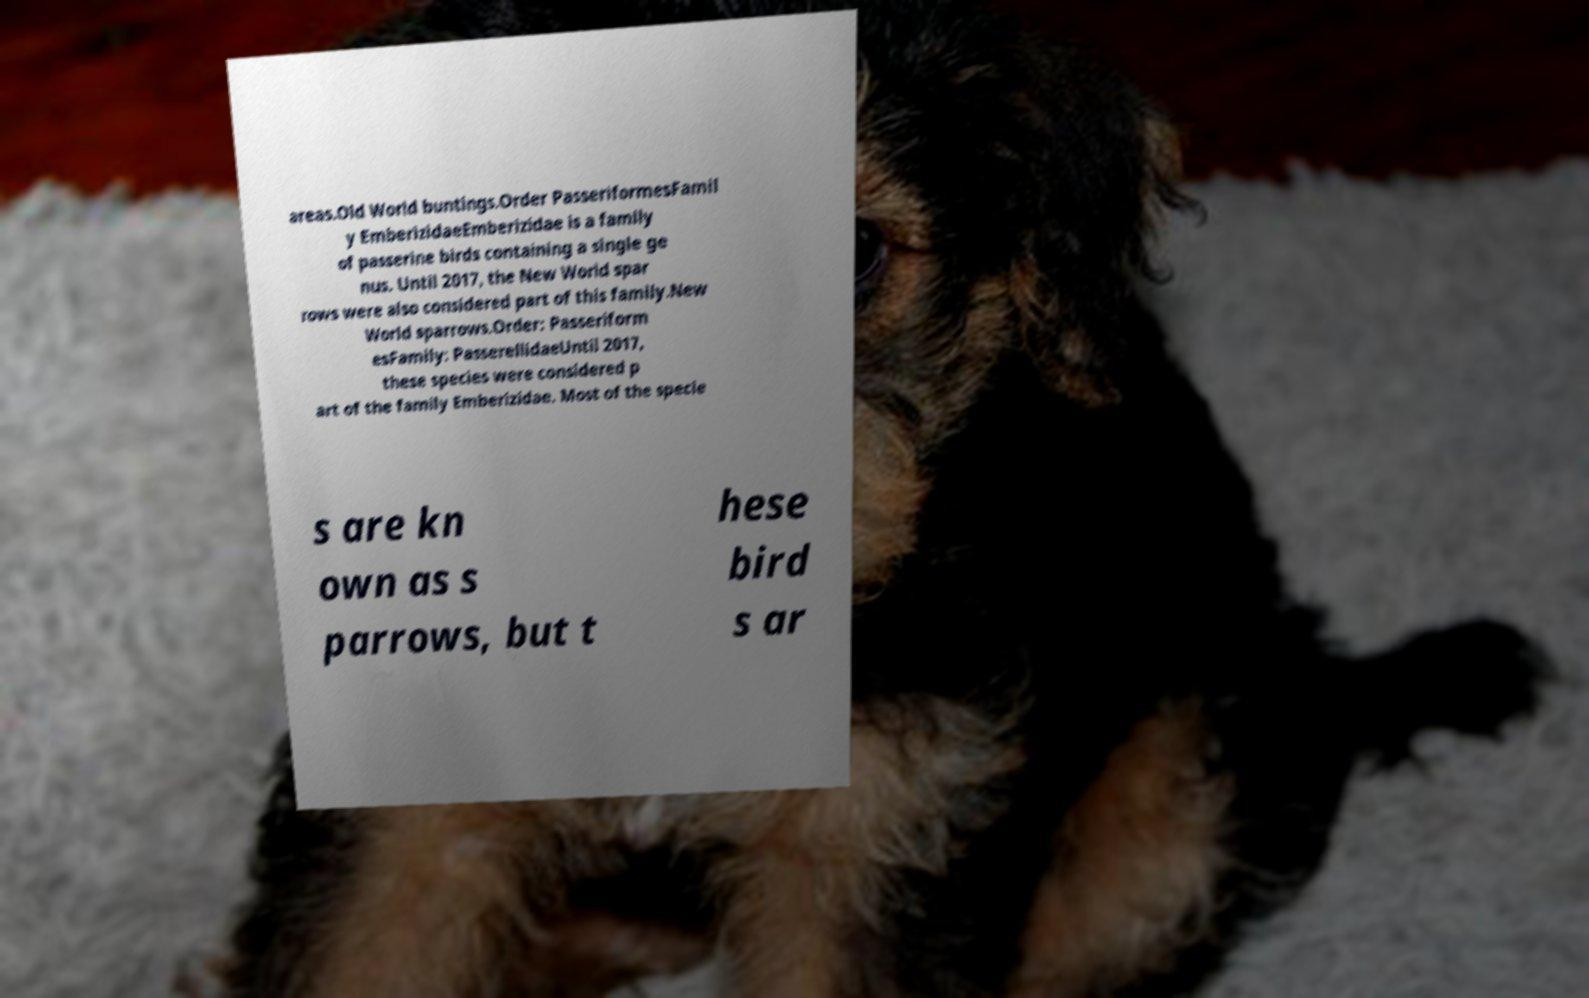Please read and relay the text visible in this image. What does it say? areas.Old World buntings.Order PasseriformesFamil y EmberizidaeEmberizidae is a family of passerine birds containing a single ge nus. Until 2017, the New World spar rows were also considered part of this family.New World sparrows.Order: Passeriform esFamily: PasserellidaeUntil 2017, these species were considered p art of the family Emberizidae. Most of the specie s are kn own as s parrows, but t hese bird s ar 